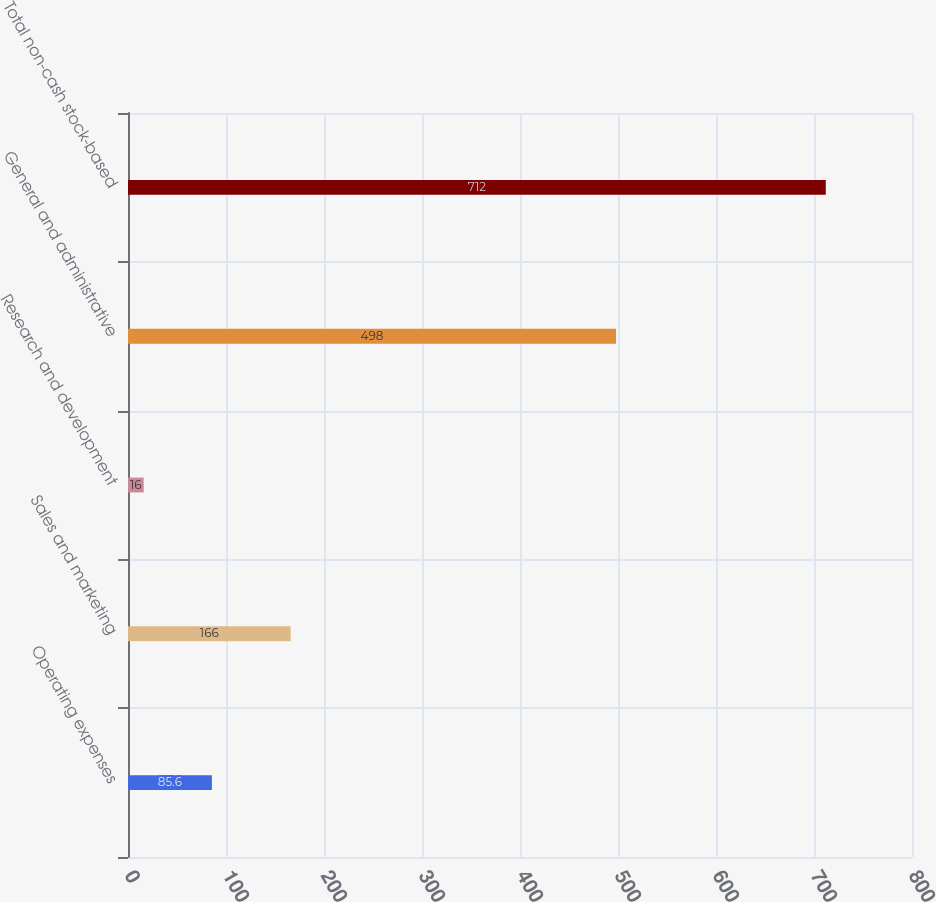Convert chart to OTSL. <chart><loc_0><loc_0><loc_500><loc_500><bar_chart><fcel>Operating expenses<fcel>Sales and marketing<fcel>Research and development<fcel>General and administrative<fcel>Total non-cash stock-based<nl><fcel>85.6<fcel>166<fcel>16<fcel>498<fcel>712<nl></chart> 